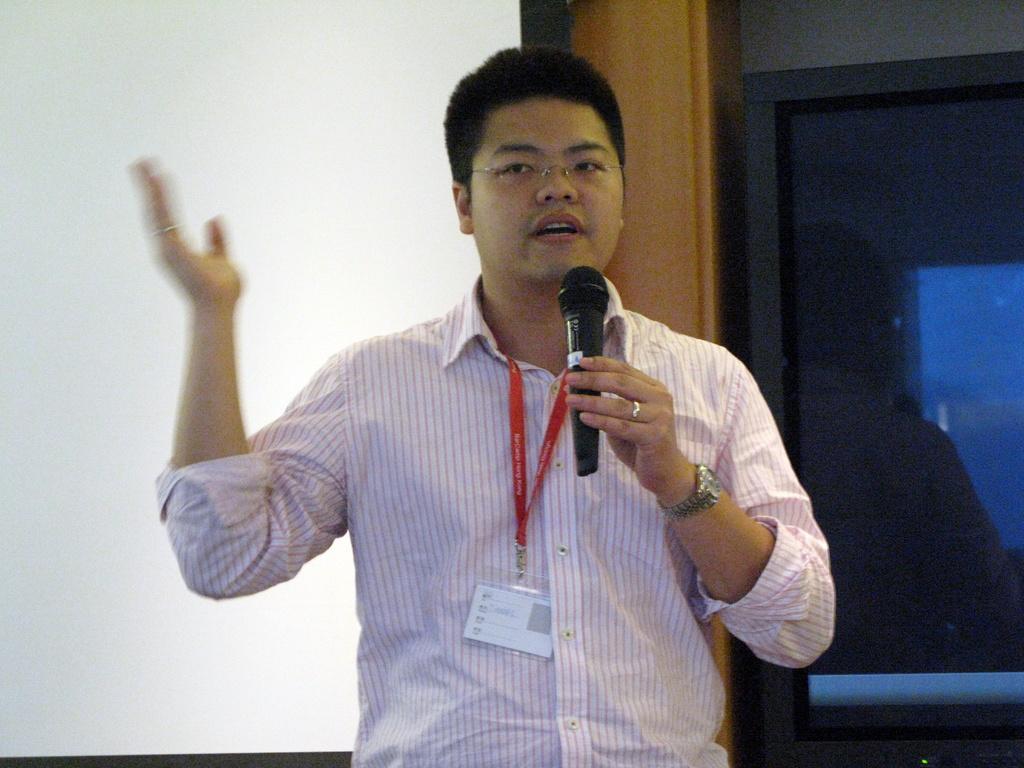Could you give a brief overview of what you see in this image? In the foreground I can see a person is holding a mike in hand. In the background I can see a screen, wall, pillar and glass object. This image is taken may be in a hall. 